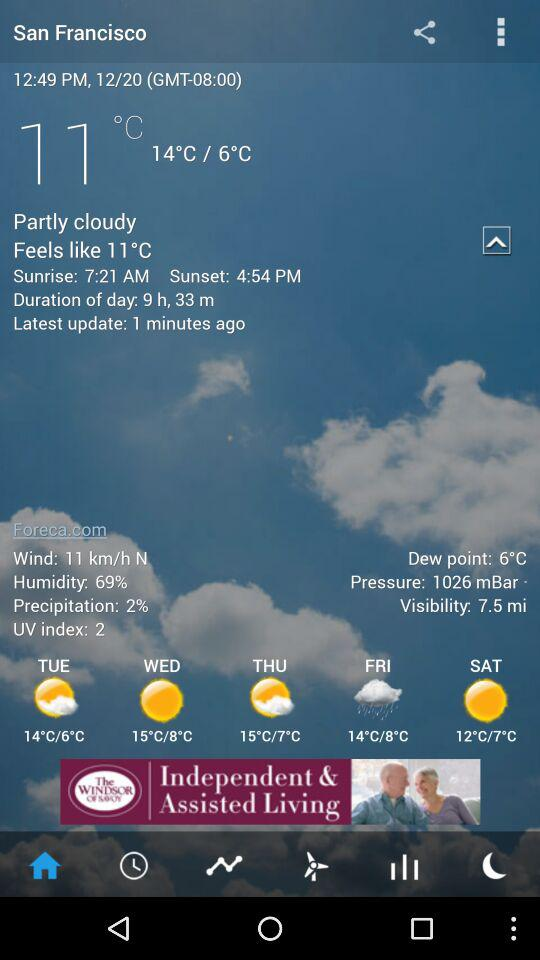What is the difference in temperature between the highest and lowest temperatures for today?
Answer the question using a single word or phrase. 8°C 